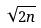<formula> <loc_0><loc_0><loc_500><loc_500>\sqrt { 2 n }</formula> 